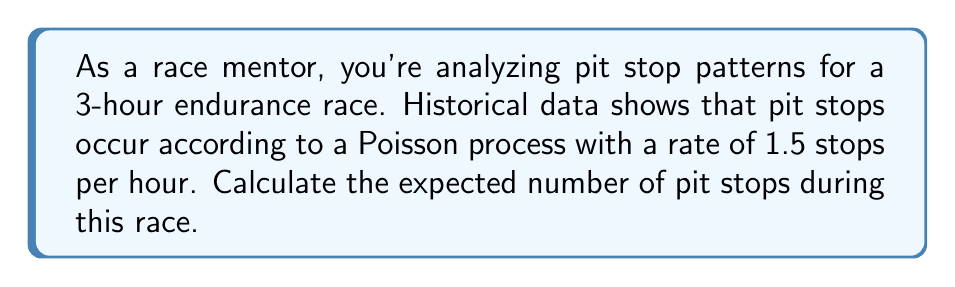Show me your answer to this math problem. To solve this problem, we'll use the properties of the Poisson process:

1. The number of events (pit stops) in a fixed time interval follows a Poisson distribution.
2. The expected number of events in an interval is proportional to the length of the interval.

Let's proceed step-by-step:

1. Define the variables:
   $\lambda$ = rate of pit stops per hour = 1.5
   $t$ = duration of the race in hours = 3

2. In a Poisson process, the expected number of events $E[N(t)]$ in time $t$ is given by:
   $$E[N(t)] = \lambda t$$

3. Substitute the values:
   $$E[N(3)] = 1.5 \times 3$$

4. Calculate:
   $$E[N(3)] = 4.5$$

Therefore, the expected number of pit stops during the 3-hour race is 4.5.
Answer: 4.5 pit stops 